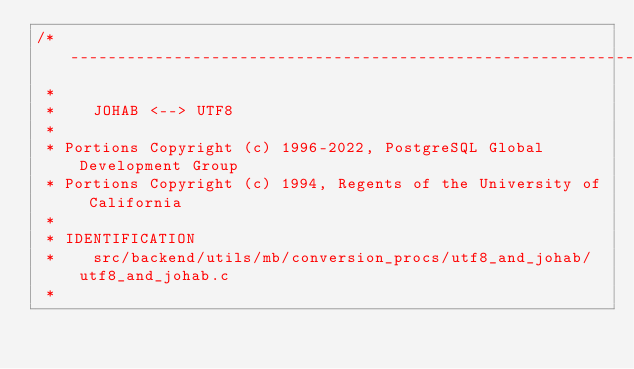Convert code to text. <code><loc_0><loc_0><loc_500><loc_500><_C_>/*-------------------------------------------------------------------------
 *
 *	  JOHAB <--> UTF8
 *
 * Portions Copyright (c) 1996-2022, PostgreSQL Global Development Group
 * Portions Copyright (c) 1994, Regents of the University of California
 *
 * IDENTIFICATION
 *	  src/backend/utils/mb/conversion_procs/utf8_and_johab/utf8_and_johab.c
 *</code> 